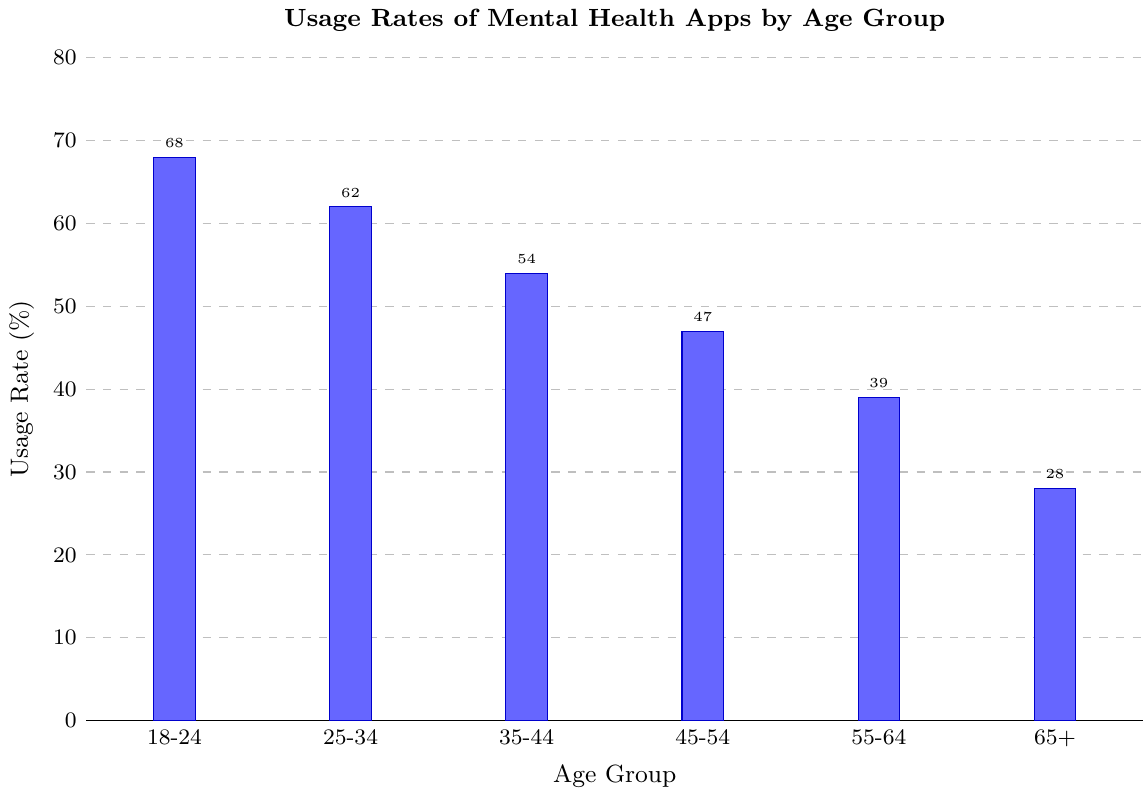What is the age group with the highest usage rate of mental health apps? To determine this, we look at the bar that is highest on the graph. The 18-24 age group has the highest bar at 68%.
Answer: 18-24 Which age group has the lowest usage rate of mental health apps? This can be identified by finding the shortest bar on the graph. The 65+ age group has the lowest bar at 28%.
Answer: 65+ What is the difference in usage rates between the age groups 18-24 and 35-44? Subtract the usage rate of the 35-44 age group from the 18-24 age group: 68% - 54% = 14%.
Answer: 14% What is the average usage rate of mental health apps for all age groups shown? Add up the usage rates for all age groups and then divide by the number of age groups: (68 + 62 + 54 + 47 + 39 + 28) / 6 = 49.67%.
Answer: 49.67 Which age group has a usage rate that is closest to the average usage rate? Calculate the average first (49.67%). Then, find the age group whose usage rate is closest to this value. The 45-54 age group has a usage rate of 47%, which is closest to 49.67%.
Answer: 45-54 How much higher is the usage rate for the 18-24 age group compared to the 55-64 age group? Subtract the usage rate of the 55-64 age group from the 18-24 age group: 68% - 39% = 29%.
Answer: 29% Which two age groups have a difference in usage rates of 15 percentage points? Check the differences between all adjacent age groups first: (68-62=6), (62-54=8), (54-47=7), (47-39=8), (39-28=11). None fit exactly, but cross-check non-adjacent groups. The 18-24 and 35-44 groups have a difference of 68 - 54 = 14%, which is close but incorrect. Thus, no exact 15 percentage point match.
Answer: None What are the combined usage rates of the 18-24 and 25-34 age groups? Add up the usage rates of these two age groups: 68% + 62% = 130%.
Answer: 130 Is the usage rate for the 25-34 age group more than twice the rate for the 65+ age group? First, calculate twice the 65+ age group usage rate: 2 * 28% = 56%. Then, compare it to the 25-34 age group’s rate of 62%. Since 62% is greater than 56%, the answer is yes.
Answer: Yes 